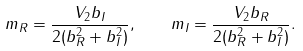Convert formula to latex. <formula><loc_0><loc_0><loc_500><loc_500>m _ { R } = \frac { V _ { 2 } b _ { I } } { 2 ( b _ { R } ^ { 2 } + b _ { I } ^ { 2 } ) } , \quad m _ { I } = \frac { V _ { 2 } b _ { R } } { 2 ( b _ { R } ^ { 2 } + b _ { I } ^ { 2 } ) } .</formula> 